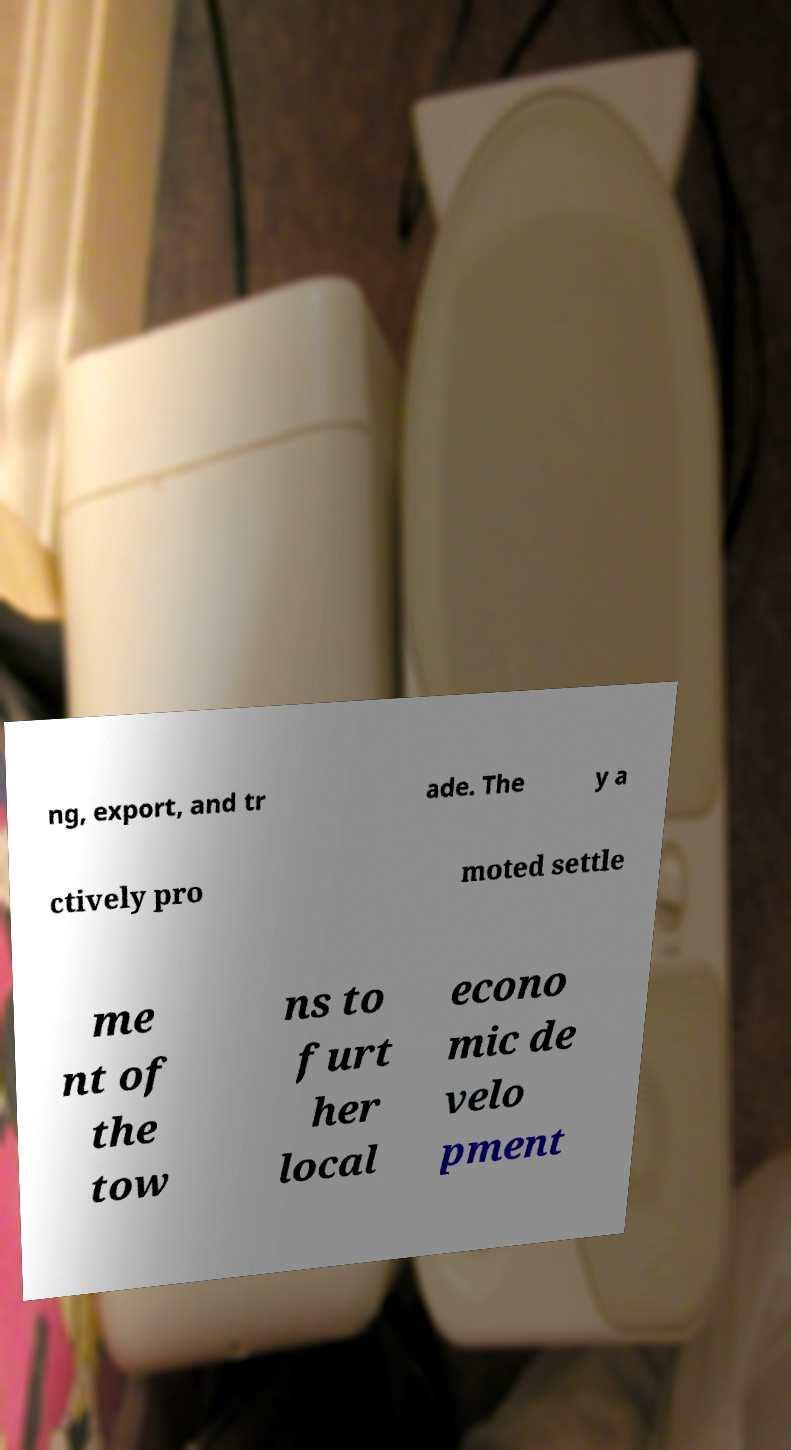Could you extract and type out the text from this image? ng, export, and tr ade. The y a ctively pro moted settle me nt of the tow ns to furt her local econo mic de velo pment 